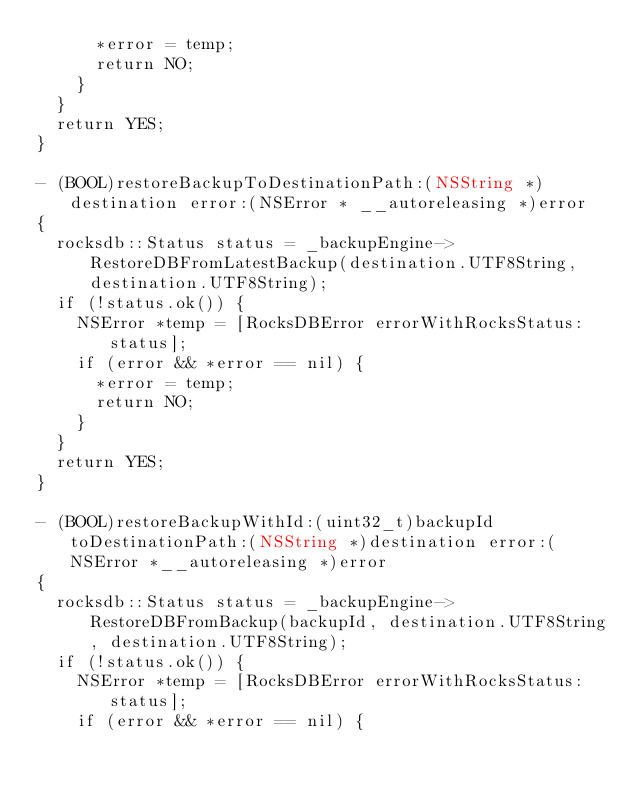Convert code to text. <code><loc_0><loc_0><loc_500><loc_500><_ObjectiveC_>			*error = temp;
			return NO;
		}
	}
	return YES;
}

- (BOOL)restoreBackupToDestinationPath:(NSString *)destination error:(NSError * __autoreleasing *)error
{
	rocksdb::Status status = _backupEngine->RestoreDBFromLatestBackup(destination.UTF8String, destination.UTF8String);
	if (!status.ok()) {
		NSError *temp = [RocksDBError errorWithRocksStatus:status];
		if (error && *error == nil) {
			*error = temp;
			return NO;
		}
	}
	return YES;
}

- (BOOL)restoreBackupWithId:(uint32_t)backupId toDestinationPath:(NSString *)destination error:(NSError *__autoreleasing *)error
{
	rocksdb::Status status = _backupEngine->RestoreDBFromBackup(backupId, destination.UTF8String, destination.UTF8String);
	if (!status.ok()) {
		NSError *temp = [RocksDBError errorWithRocksStatus:status];
		if (error && *error == nil) {</code> 